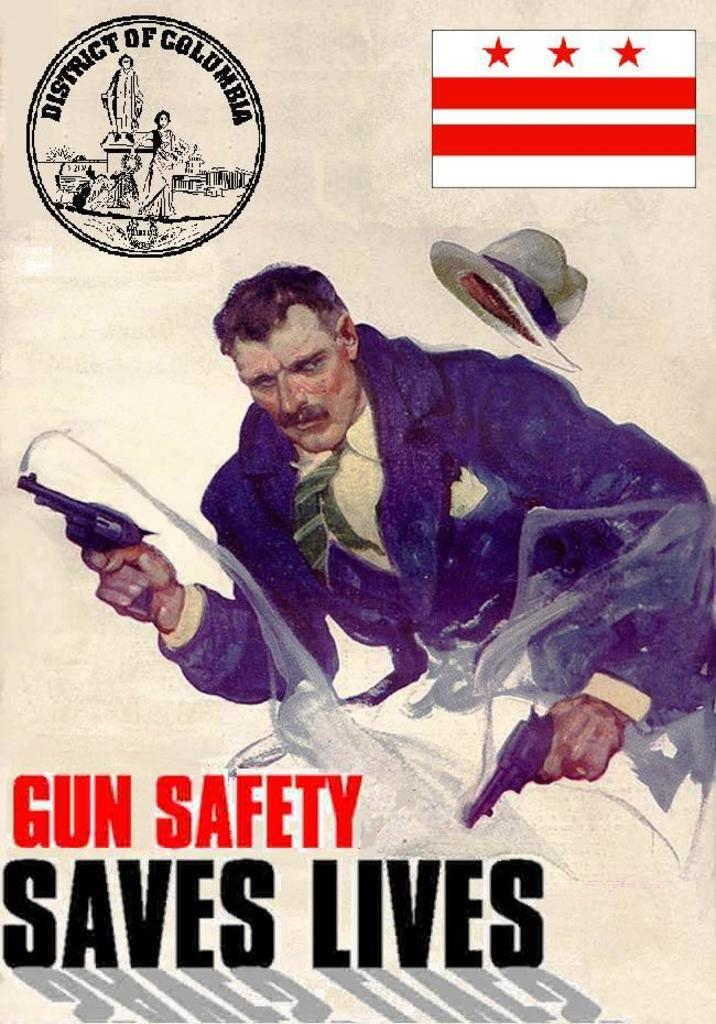What is the main object in the image? There is a poster in the image. What can be found at the bottom of the poster? There is text at the bottom of the poster. What is the person in the middle of the poster holding? The person is holding pistols in the middle of the poster. What is located at the top of the poster? There is a flag, an emblem, and a hat at the top of the poster. How does the person in the poster rest during a rainstorm? There is no indication of a rainstorm or the person resting in the image; the focus is on the person holding pistols. What type of sponge is used to clean the emblem on the poster? There is no mention of a sponge or cleaning in the image; the focus is on the various elements of the poster. 